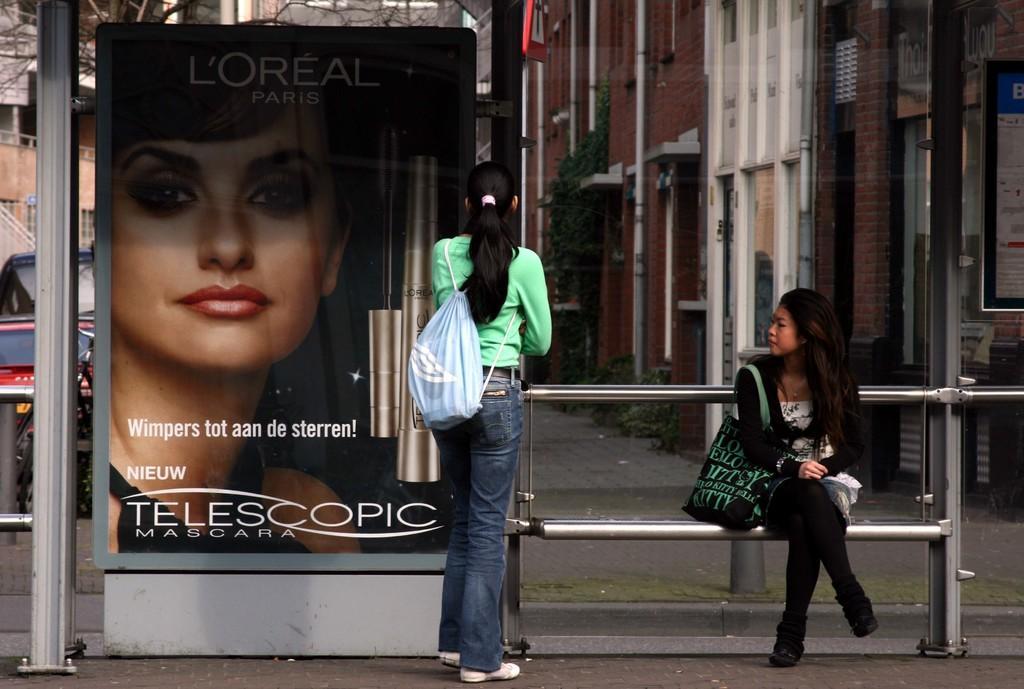How would you summarize this image in a sentence or two? In this image, I can see the woman sitting on the bench. Here is another woman standing. She wore a backpack bag. This looks like a poster. Here is a pole. In the background, these are the buildings with windows. This looks like a tree. 